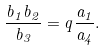<formula> <loc_0><loc_0><loc_500><loc_500>\frac { b _ { 1 } b _ { 2 } } { b _ { 3 } } = q \frac { a _ { 1 } } { a _ { 4 } } .</formula> 